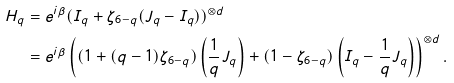<formula> <loc_0><loc_0><loc_500><loc_500>H _ { q } & = e ^ { i \beta } ( I _ { q } + \zeta _ { 6 - q } ( J _ { q } - I _ { q } ) ) ^ { \otimes d } \\ & = e ^ { i \beta } \left ( ( 1 + ( q - 1 ) \zeta _ { 6 - q } ) \left ( \frac { 1 } { q } J _ { q } \right ) + ( 1 - \zeta _ { 6 - q } ) \left ( I _ { q } - \frac { 1 } { q } J _ { q } \right ) \right ) ^ { \otimes d } .</formula> 